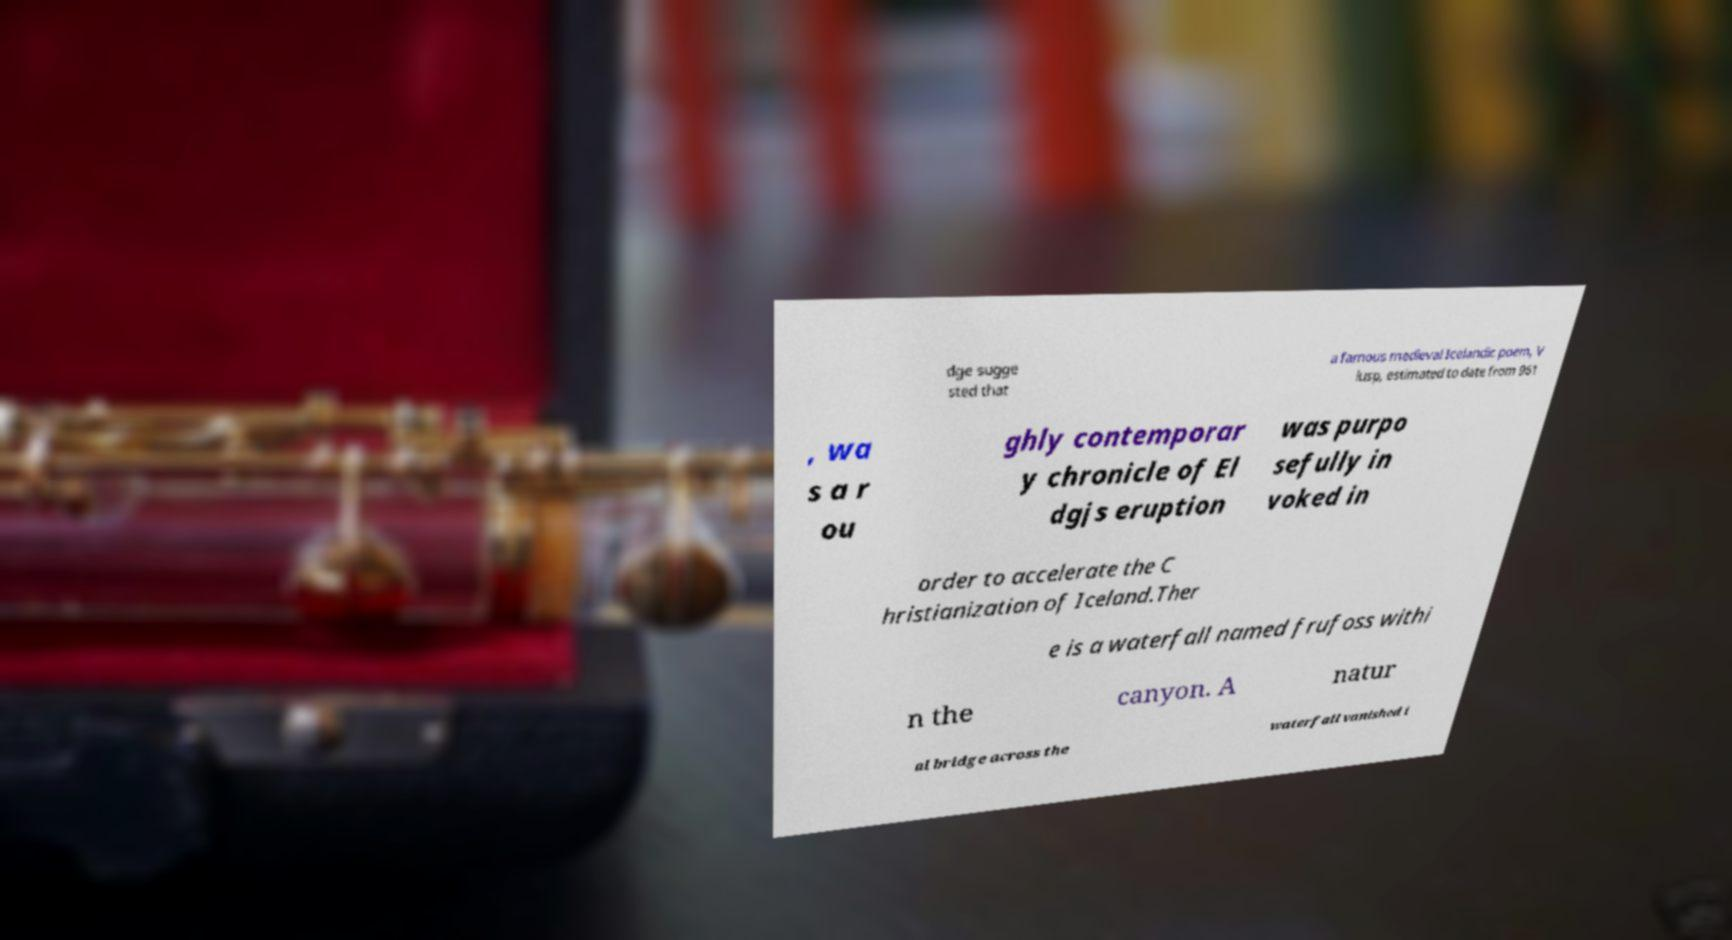Can you accurately transcribe the text from the provided image for me? dge sugge sted that a famous medieval Icelandic poem, V lusp, estimated to date from 961 , wa s a r ou ghly contemporar y chronicle of El dgjs eruption was purpo sefully in voked in order to accelerate the C hristianization of Iceland.Ther e is a waterfall named frufoss withi n the canyon. A natur al bridge across the waterfall vanished i 